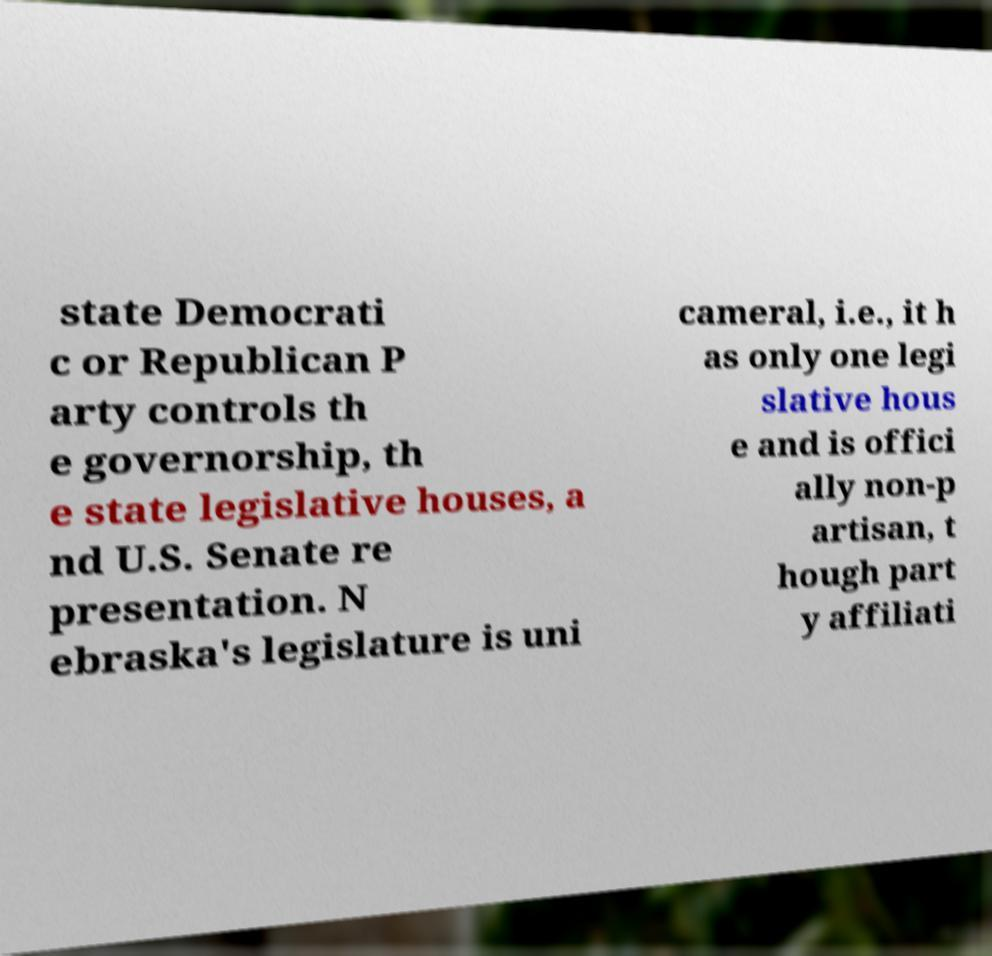Can you accurately transcribe the text from the provided image for me? state Democrati c or Republican P arty controls th e governorship, th e state legislative houses, a nd U.S. Senate re presentation. N ebraska's legislature is uni cameral, i.e., it h as only one legi slative hous e and is offici ally non-p artisan, t hough part y affiliati 